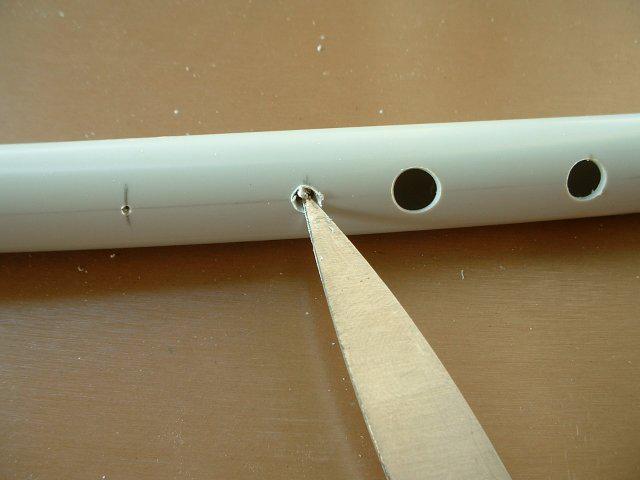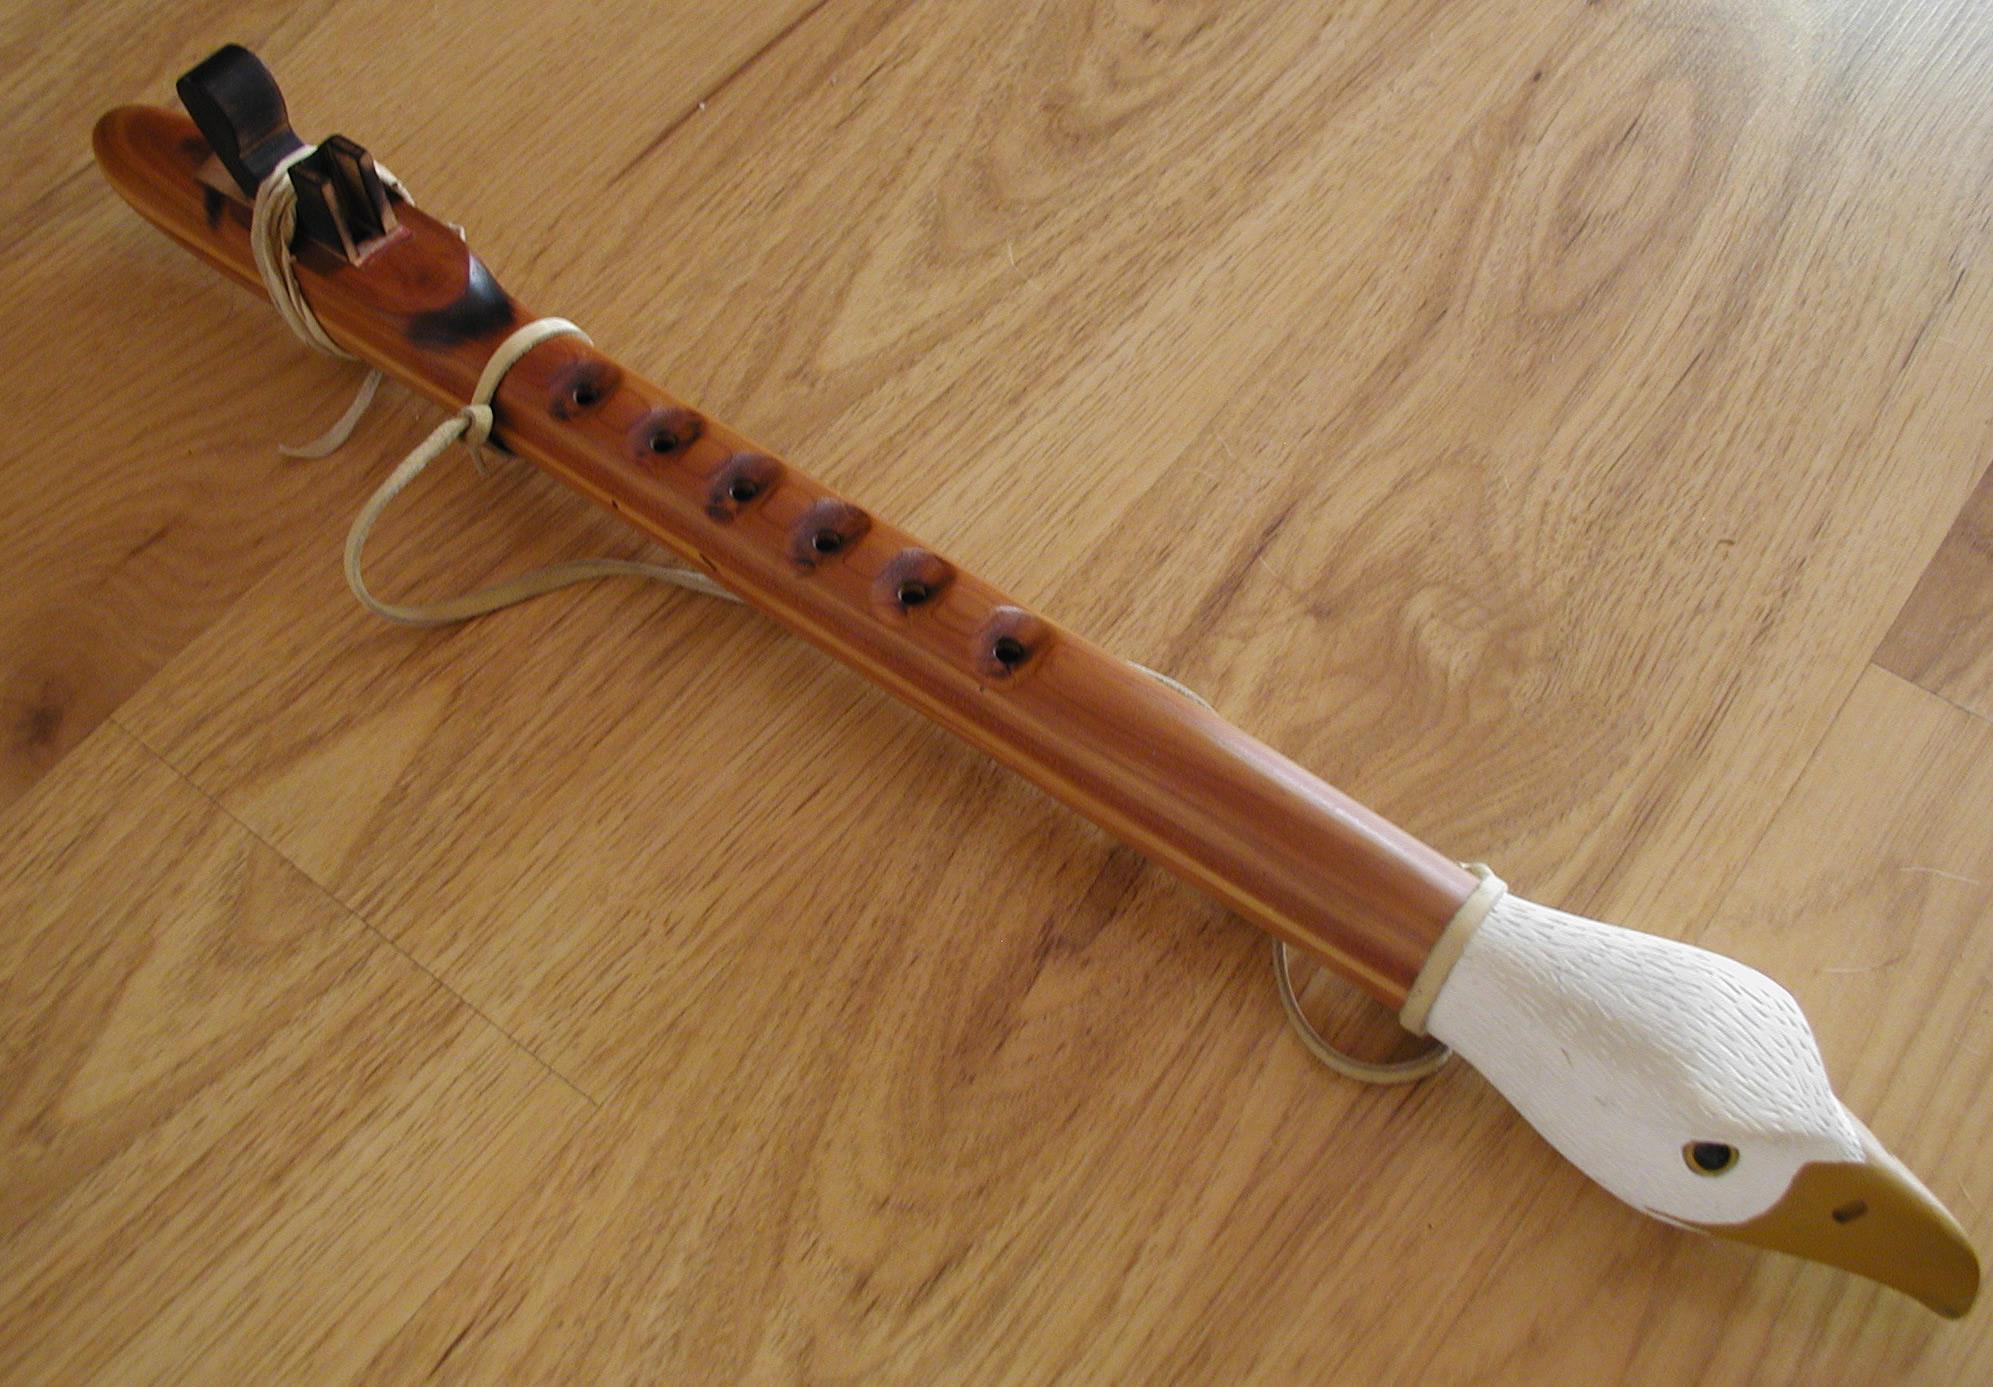The first image is the image on the left, the second image is the image on the right. Considering the images on both sides, is "A sharp object sits near a pipe in the image on the left." valid? Answer yes or no. Yes. The first image is the image on the left, the second image is the image on the right. Evaluate the accuracy of this statement regarding the images: "The left image shows a white PVC-look tube with a cut part and a metal-bladed tool near it.". Is it true? Answer yes or no. Yes. 